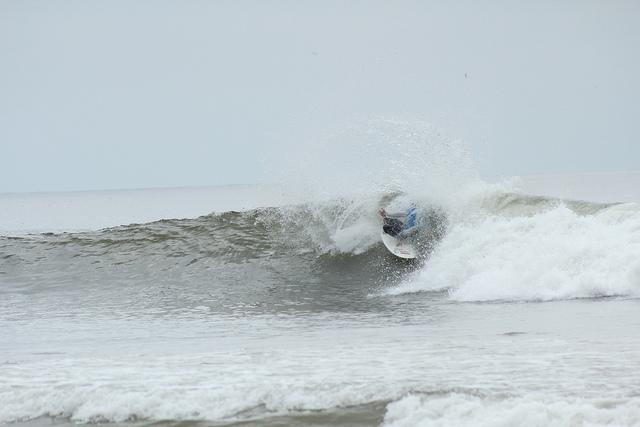What type of Board is in this image?
Concise answer only. Surfboard. Is anyone swimming?
Answer briefly. No. Overcast or sunny?
Quick response, please. Overcast. 